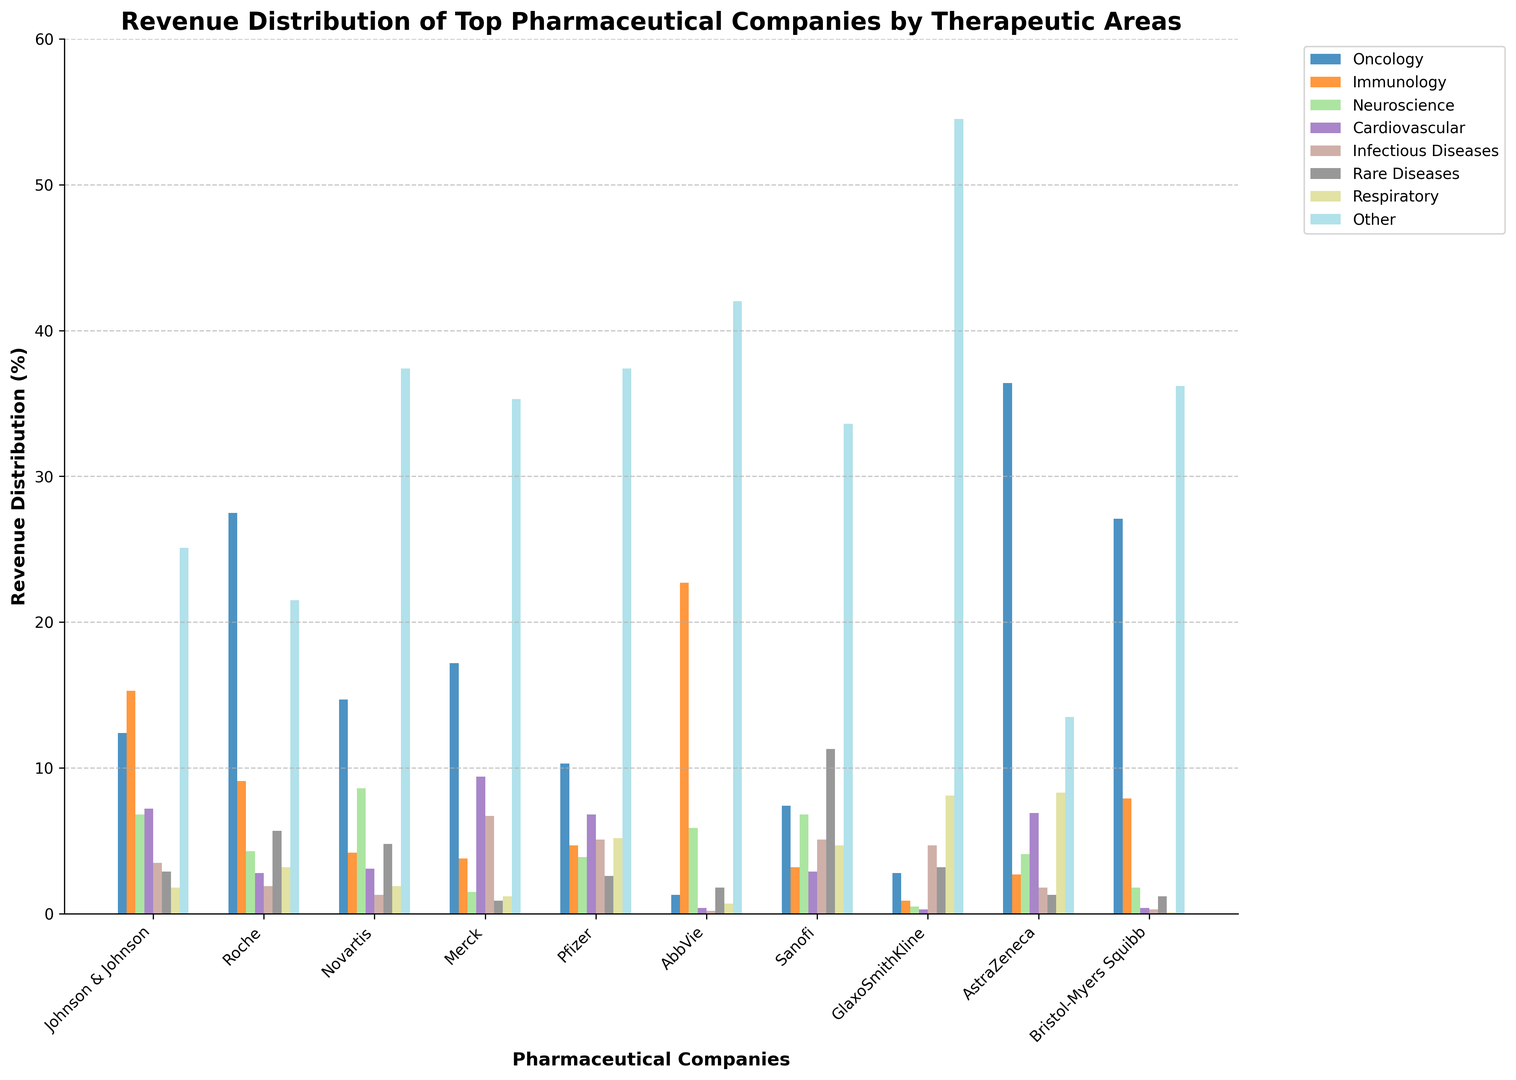What's the total percentage revenue for Cardiovascular and Immunology for Pfizer? To find the total percentage revenue for Pfizer in Cardiovascular and Immunology, sum the two values. According to the data: Cardiovascular is 6.8 and Immunology is 4.7. So, the total is 6.8 + 4.7 = 11.5
Answer: 11.5 Which company has the highest revenue distribution in Oncology? Look at the Oncology category for all companies and identify the highest value. According to the data, AstraZeneca has the highest revenue distribution in Oncology with 36.4
Answer: AstraZeneca Between Roche and Novartis, which company has higher revenue in Rare Diseases, and by how much? For Roche, Rare Diseases revenue is 5.7, and for Novartis, it is 4.8. The difference is 5.7 - 4.8 = 0.9. Roche has higher revenue in Rare Diseases by 0.9
Answer: Roche, by 0.9 Summing up the revenue percentages for Infectious Diseases across all companies, what is the total percentage? Sum the values for Infectious Diseases across all companies: 3.5 + 1.9 + 1.3 + 6.7 + 5.1 + 0.2 + 5.1 + 4.7 + 1.8 + 0.3 = 30.6
Answer: 30.6 Which therapeutic area does GlaxoSmithKline have the highest revenue distribution in? Look at the revenue distribution for GlaxoSmithKline across all therapeutic areas and identify the highest value. According to the data, 'Other' has the highest revenue distribution with 54.5
Answer: Other Compare the revenue distribution in Neuroscience between Sanofi and Pfizer, which company has a larger share and by what margin? For Neuroscience, Sanofi has 6.8 and Pfizer has 3.9. The difference is 6.8 - 3.9 = 2.9. Sanofi has a larger share by 2.9
Answer: Sanofi, by 2.9 What is the average revenue distribution in Immunology for Johnson & Johnson, Merck, and Bristol-Myers Squibb? Average revenue distribution is calculated by summing the values and dividing by the number of observations. For Immunology: J&J = 15.3, Merck = 3.8, BMS = 7.9. Sum = 15.3 + 3.8 + 7.9 = 27. Divide by 3: 27 / 3 = 9.0
Answer: 9.0 Which companies have their highest revenue distribution in the 'Other' category? Look for companies where the highest percentage value is in the 'Other' category. According to the data, Novartis, AbbVie, GlaxoSmithKline, and Bristol-Myers Squibb have their highest revenue in 'Other'
Answer: Novartis, AbbVie, GlaxoSmithKline, Bristol-Myers Squibb 